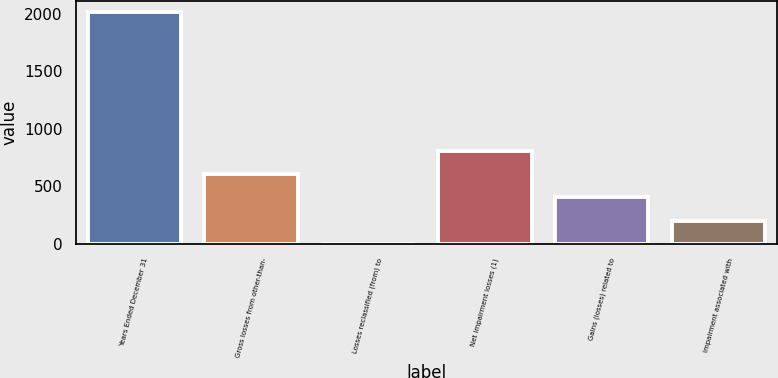Convert chart. <chart><loc_0><loc_0><loc_500><loc_500><bar_chart><fcel>Years Ended December 31<fcel>Gross losses from other-than-<fcel>Losses reclassified (from) to<fcel>Net impairment losses (1)<fcel>Gains (losses) related to<fcel>Impairment associated with<nl><fcel>2013<fcel>605.3<fcel>2<fcel>806.4<fcel>404.2<fcel>203.1<nl></chart> 